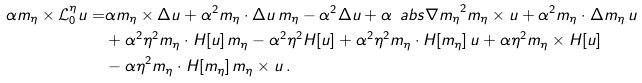Convert formula to latex. <formula><loc_0><loc_0><loc_500><loc_500>\alpha m _ { \eta } \times \mathcal { L } ^ { \eta } _ { 0 } u = & \alpha m _ { \eta } \times \Delta u + \alpha ^ { 2 } m _ { \eta } \cdot \Delta u \, m _ { \eta } - \alpha ^ { 2 } \Delta u + \alpha \, \ a b s { \nabla m _ { \eta } } ^ { 2 } m _ { \eta } \times u + \alpha ^ { 2 } m _ { \eta } \cdot \Delta m _ { \eta } \, u \\ & + \alpha ^ { 2 } \eta ^ { 2 } m _ { \eta } \cdot H [ u ] \, m _ { \eta } - \alpha ^ { 2 } \eta ^ { 2 } H [ u ] + \alpha ^ { 2 } \eta ^ { 2 } m _ { \eta } \cdot H [ m _ { \eta } ] \, u + \alpha \eta ^ { 2 } m _ { \eta } \times H [ u ] \\ & - \alpha \eta ^ { 2 } m _ { \eta } \cdot H [ m _ { \eta } ] \, m _ { \eta } \times u \, .</formula> 